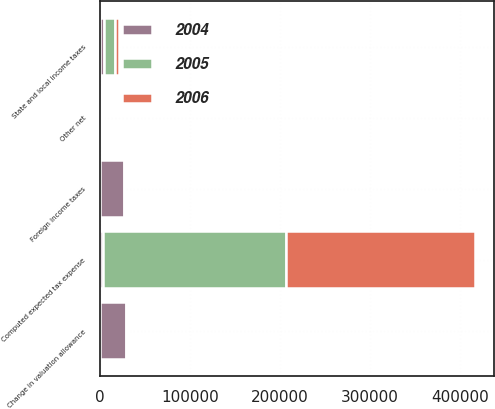<chart> <loc_0><loc_0><loc_500><loc_500><stacked_bar_chart><ecel><fcel>Computed expected tax expense<fcel>State and local income taxes<fcel>Foreign income taxes<fcel>Change in valuation allowance<fcel>Other net<nl><fcel>2004<fcel>3401.5<fcel>4522<fcel>26280<fcel>28608<fcel>957<nl><fcel>2006<fcel>210747<fcel>4748<fcel>589<fcel>1351<fcel>1440<nl><fcel>2005<fcel>203277<fcel>11711<fcel>892<fcel>1821<fcel>2281<nl></chart> 